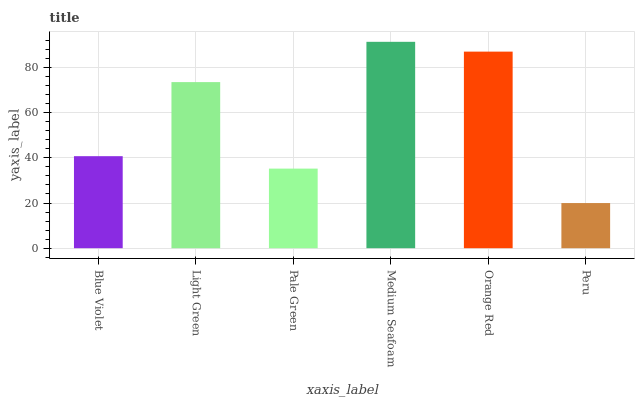Is Peru the minimum?
Answer yes or no. Yes. Is Medium Seafoam the maximum?
Answer yes or no. Yes. Is Light Green the minimum?
Answer yes or no. No. Is Light Green the maximum?
Answer yes or no. No. Is Light Green greater than Blue Violet?
Answer yes or no. Yes. Is Blue Violet less than Light Green?
Answer yes or no. Yes. Is Blue Violet greater than Light Green?
Answer yes or no. No. Is Light Green less than Blue Violet?
Answer yes or no. No. Is Light Green the high median?
Answer yes or no. Yes. Is Blue Violet the low median?
Answer yes or no. Yes. Is Blue Violet the high median?
Answer yes or no. No. Is Orange Red the low median?
Answer yes or no. No. 